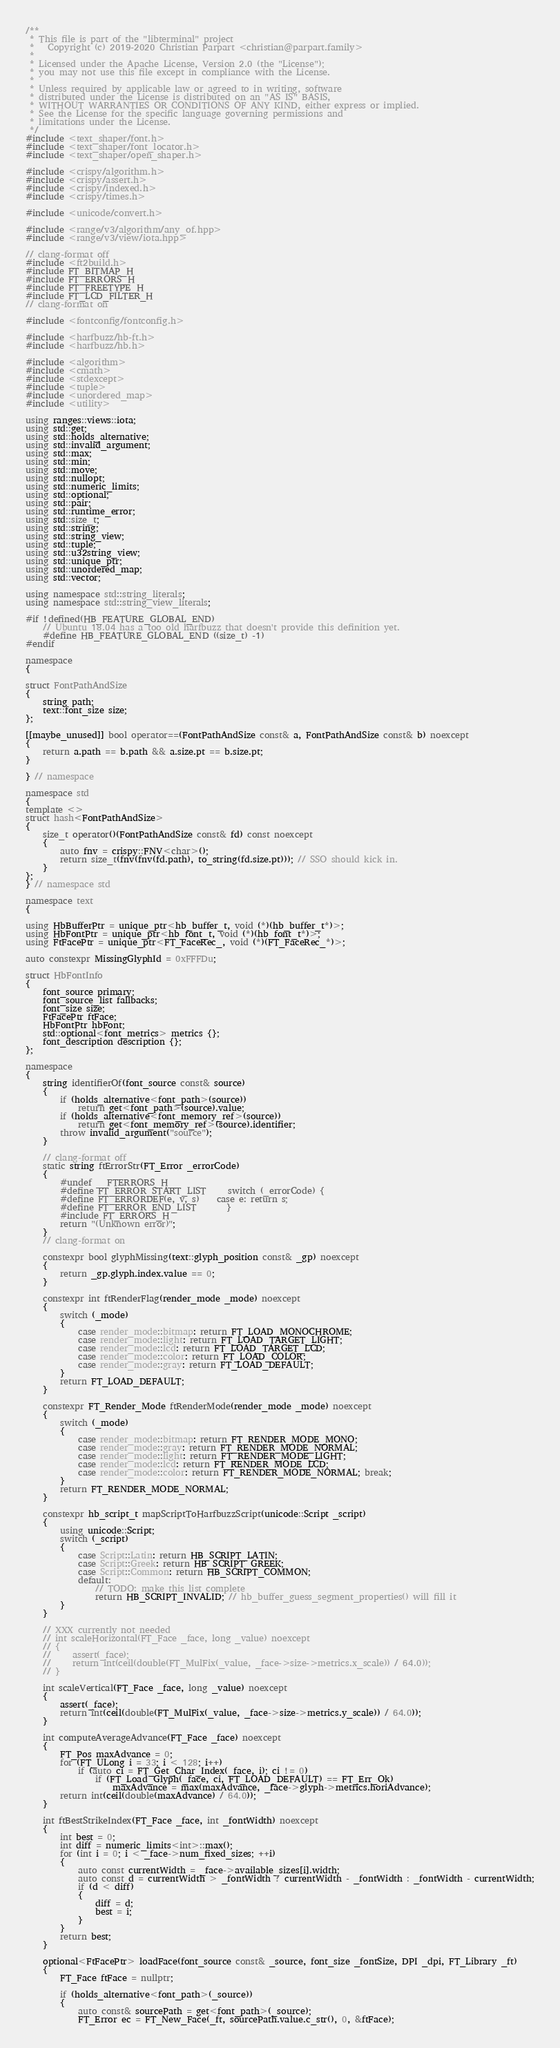Convert code to text. <code><loc_0><loc_0><loc_500><loc_500><_C++_>/**
 * This file is part of the "libterminal" project
 *   Copyright (c) 2019-2020 Christian Parpart <christian@parpart.family>
 *
 * Licensed under the Apache License, Version 2.0 (the "License");
 * you may not use this file except in compliance with the License.
 *
 * Unless required by applicable law or agreed to in writing, software
 * distributed under the License is distributed on an "AS IS" BASIS,
 * WITHOUT WARRANTIES OR CONDITIONS OF ANY KIND, either express or implied.
 * See the License for the specific language governing permissions and
 * limitations under the License.
 */
#include <text_shaper/font.h>
#include <text_shaper/font_locator.h>
#include <text_shaper/open_shaper.h>

#include <crispy/algorithm.h>
#include <crispy/assert.h>
#include <crispy/indexed.h>
#include <crispy/times.h>

#include <unicode/convert.h>

#include <range/v3/algorithm/any_of.hpp>
#include <range/v3/view/iota.hpp>

// clang-format off
#include <ft2build.h>
#include FT_BITMAP_H
#include FT_ERRORS_H
#include FT_FREETYPE_H
#include FT_LCD_FILTER_H
// clang-format on

#include <fontconfig/fontconfig.h>

#include <harfbuzz/hb-ft.h>
#include <harfbuzz/hb.h>

#include <algorithm>
#include <cmath>
#include <stdexcept>
#include <tuple>
#include <unordered_map>
#include <utility>

using ranges::views::iota;
using std::get;
using std::holds_alternative;
using std::invalid_argument;
using std::max;
using std::min;
using std::move;
using std::nullopt;
using std::numeric_limits;
using std::optional;
using std::pair;
using std::runtime_error;
using std::size_t;
using std::string;
using std::string_view;
using std::tuple;
using std::u32string_view;
using std::unique_ptr;
using std::unordered_map;
using std::vector;

using namespace std::string_literals;
using namespace std::string_view_literals;

#if !defined(HB_FEATURE_GLOBAL_END)
    // Ubuntu 18.04 has a too old harfbuzz that doesn't provide this definition yet.
    #define HB_FEATURE_GLOBAL_END ((size_t) -1)
#endif

namespace
{

struct FontPathAndSize
{
    string path;
    text::font_size size;
};

[[maybe_unused]] bool operator==(FontPathAndSize const& a, FontPathAndSize const& b) noexcept
{
    return a.path == b.path && a.size.pt == b.size.pt;
}

} // namespace

namespace std
{
template <>
struct hash<FontPathAndSize>
{
    size_t operator()(FontPathAndSize const& fd) const noexcept
    {
        auto fnv = crispy::FNV<char>();
        return size_t(fnv(fnv(fd.path), to_string(fd.size.pt))); // SSO should kick in.
    }
};
} // namespace std

namespace text
{

using HbBufferPtr = unique_ptr<hb_buffer_t, void (*)(hb_buffer_t*)>;
using HbFontPtr = unique_ptr<hb_font_t, void (*)(hb_font_t*)>;
using FtFacePtr = unique_ptr<FT_FaceRec_, void (*)(FT_FaceRec_*)>;

auto constexpr MissingGlyphId = 0xFFFDu;

struct HbFontInfo
{
    font_source primary;
    font_source_list fallbacks;
    font_size size;
    FtFacePtr ftFace;
    HbFontPtr hbFont;
    std::optional<font_metrics> metrics {};
    font_description description {};
};

namespace
{
    string identifierOf(font_source const& source)
    {
        if (holds_alternative<font_path>(source))
            return get<font_path>(source).value;
        if (holds_alternative<font_memory_ref>(source))
            return get<font_memory_ref>(source).identifier;
        throw invalid_argument("source");
    }

    // clang-format off
    static string ftErrorStr(FT_Error _errorCode)
    {
        #undef __FTERRORS_H__
        #define FT_ERROR_START_LIST     switch (_errorCode) {
        #define FT_ERRORDEF(e, v, s)    case e: return s;
        #define FT_ERROR_END_LIST       }
        #include FT_ERRORS_H
        return "(Unknown error)";
    }
    // clang-format on

    constexpr bool glyphMissing(text::glyph_position const& _gp) noexcept
    {
        return _gp.glyph.index.value == 0;
    }

    constexpr int ftRenderFlag(render_mode _mode) noexcept
    {
        switch (_mode)
        {
            case render_mode::bitmap: return FT_LOAD_MONOCHROME;
            case render_mode::light: return FT_LOAD_TARGET_LIGHT;
            case render_mode::lcd: return FT_LOAD_TARGET_LCD;
            case render_mode::color: return FT_LOAD_COLOR;
            case render_mode::gray: return FT_LOAD_DEFAULT;
        }
        return FT_LOAD_DEFAULT;
    }

    constexpr FT_Render_Mode ftRenderMode(render_mode _mode) noexcept
    {
        switch (_mode)
        {
            case render_mode::bitmap: return FT_RENDER_MODE_MONO;
            case render_mode::gray: return FT_RENDER_MODE_NORMAL;
            case render_mode::light: return FT_RENDER_MODE_LIGHT;
            case render_mode::lcd: return FT_RENDER_MODE_LCD;
            case render_mode::color: return FT_RENDER_MODE_NORMAL; break;
        }
        return FT_RENDER_MODE_NORMAL;
    }

    constexpr hb_script_t mapScriptToHarfbuzzScript(unicode::Script _script)
    {
        using unicode::Script;
        switch (_script)
        {
            case Script::Latin: return HB_SCRIPT_LATIN;
            case Script::Greek: return HB_SCRIPT_GREEK;
            case Script::Common: return HB_SCRIPT_COMMON;
            default:
                // TODO: make this list complete
                return HB_SCRIPT_INVALID; // hb_buffer_guess_segment_properties() will fill it
        }
    }

    // XXX currently not needed
    // int scaleHorizontal(FT_Face _face, long _value) noexcept
    // {
    //     assert(_face);
    //     return int(ceil(double(FT_MulFix(_value, _face->size->metrics.x_scale)) / 64.0));
    // }

    int scaleVertical(FT_Face _face, long _value) noexcept
    {
        assert(_face);
        return int(ceil(double(FT_MulFix(_value, _face->size->metrics.y_scale)) / 64.0));
    }

    int computeAverageAdvance(FT_Face _face) noexcept
    {
        FT_Pos maxAdvance = 0;
        for (FT_ULong i = 33; i < 128; i++)
            if (auto ci = FT_Get_Char_Index(_face, i); ci != 0)
                if (FT_Load_Glyph(_face, ci, FT_LOAD_DEFAULT) == FT_Err_Ok)
                    maxAdvance = max(maxAdvance, _face->glyph->metrics.horiAdvance);
        return int(ceil(double(maxAdvance) / 64.0));
    }

    int ftBestStrikeIndex(FT_Face _face, int _fontWidth) noexcept
    {
        int best = 0;
        int diff = numeric_limits<int>::max();
        for (int i = 0; i < _face->num_fixed_sizes; ++i)
        {
            auto const currentWidth = _face->available_sizes[i].width;
            auto const d = currentWidth > _fontWidth ? currentWidth - _fontWidth : _fontWidth - currentWidth;
            if (d < diff)
            {
                diff = d;
                best = i;
            }
        }
        return best;
    }

    optional<FtFacePtr> loadFace(font_source const& _source, font_size _fontSize, DPI _dpi, FT_Library _ft)
    {
        FT_Face ftFace = nullptr;

        if (holds_alternative<font_path>(_source))
        {
            auto const& sourcePath = get<font_path>(_source);
            FT_Error ec = FT_New_Face(_ft, sourcePath.value.c_str(), 0, &ftFace);</code> 